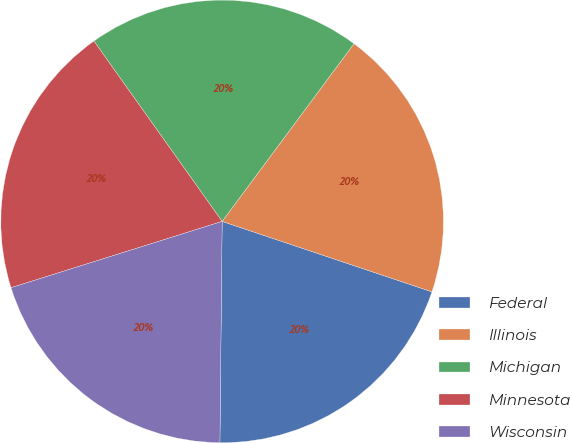Convert chart to OTSL. <chart><loc_0><loc_0><loc_500><loc_500><pie_chart><fcel>Federal<fcel>Illinois<fcel>Michigan<fcel>Minnesota<fcel>Wisconsin<nl><fcel>20.01%<fcel>20.0%<fcel>20.0%<fcel>20.01%<fcel>20.0%<nl></chart> 